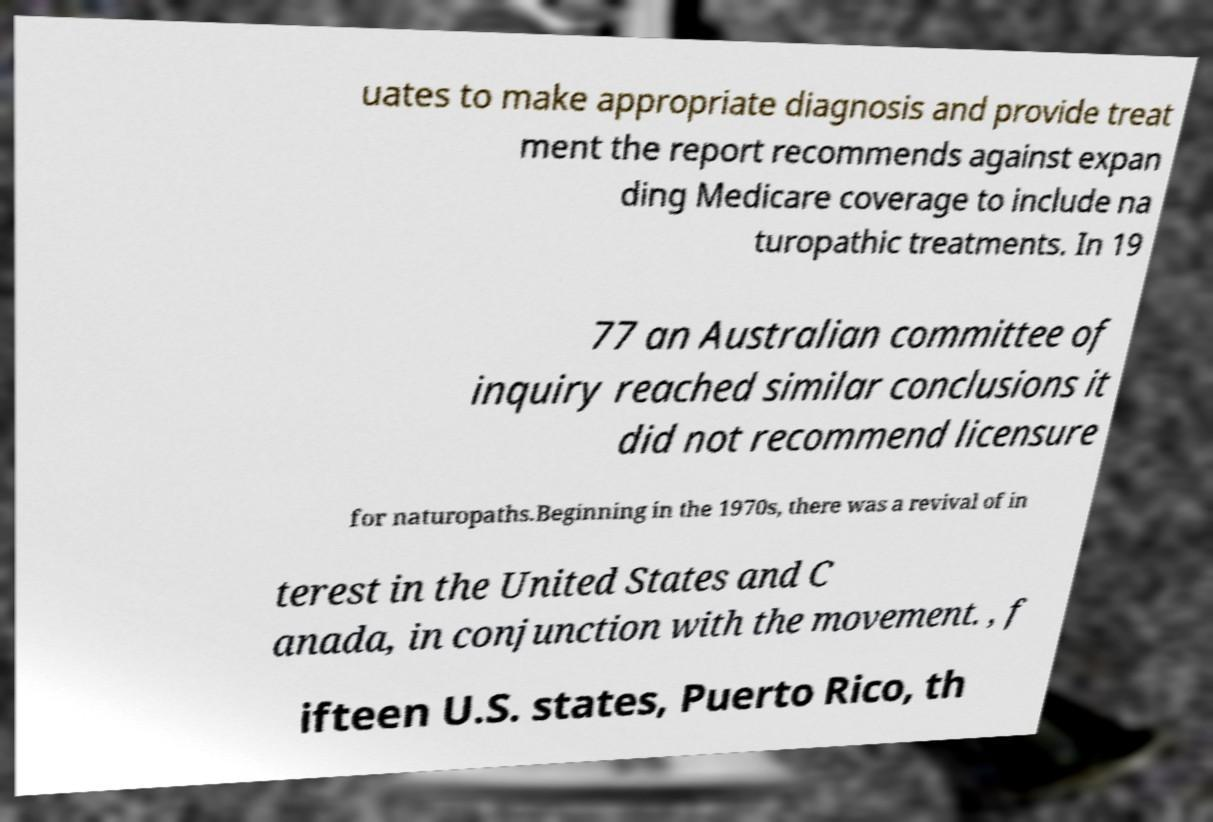Can you read and provide the text displayed in the image?This photo seems to have some interesting text. Can you extract and type it out for me? uates to make appropriate diagnosis and provide treat ment the report recommends against expan ding Medicare coverage to include na turopathic treatments. In 19 77 an Australian committee of inquiry reached similar conclusions it did not recommend licensure for naturopaths.Beginning in the 1970s, there was a revival of in terest in the United States and C anada, in conjunction with the movement. , f ifteen U.S. states, Puerto Rico, th 